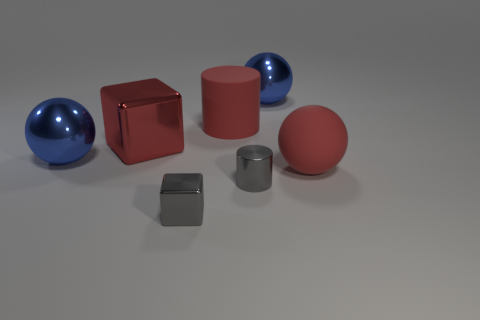Add 3 cylinders. How many objects exist? 10 Subtract all cylinders. How many objects are left? 5 Add 3 large things. How many large things exist? 8 Subtract 1 red spheres. How many objects are left? 6 Subtract all big metal cubes. Subtract all metallic things. How many objects are left? 1 Add 5 blue things. How many blue things are left? 7 